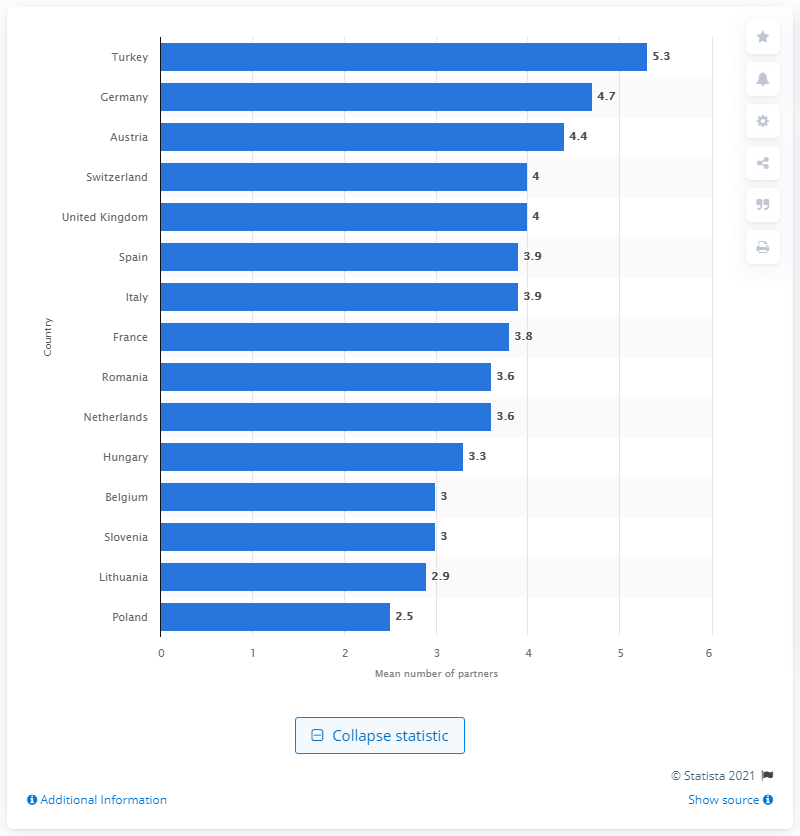List a handful of essential elements in this visual. In 2010, the average number of sex partners in Turkey was 5.3. 